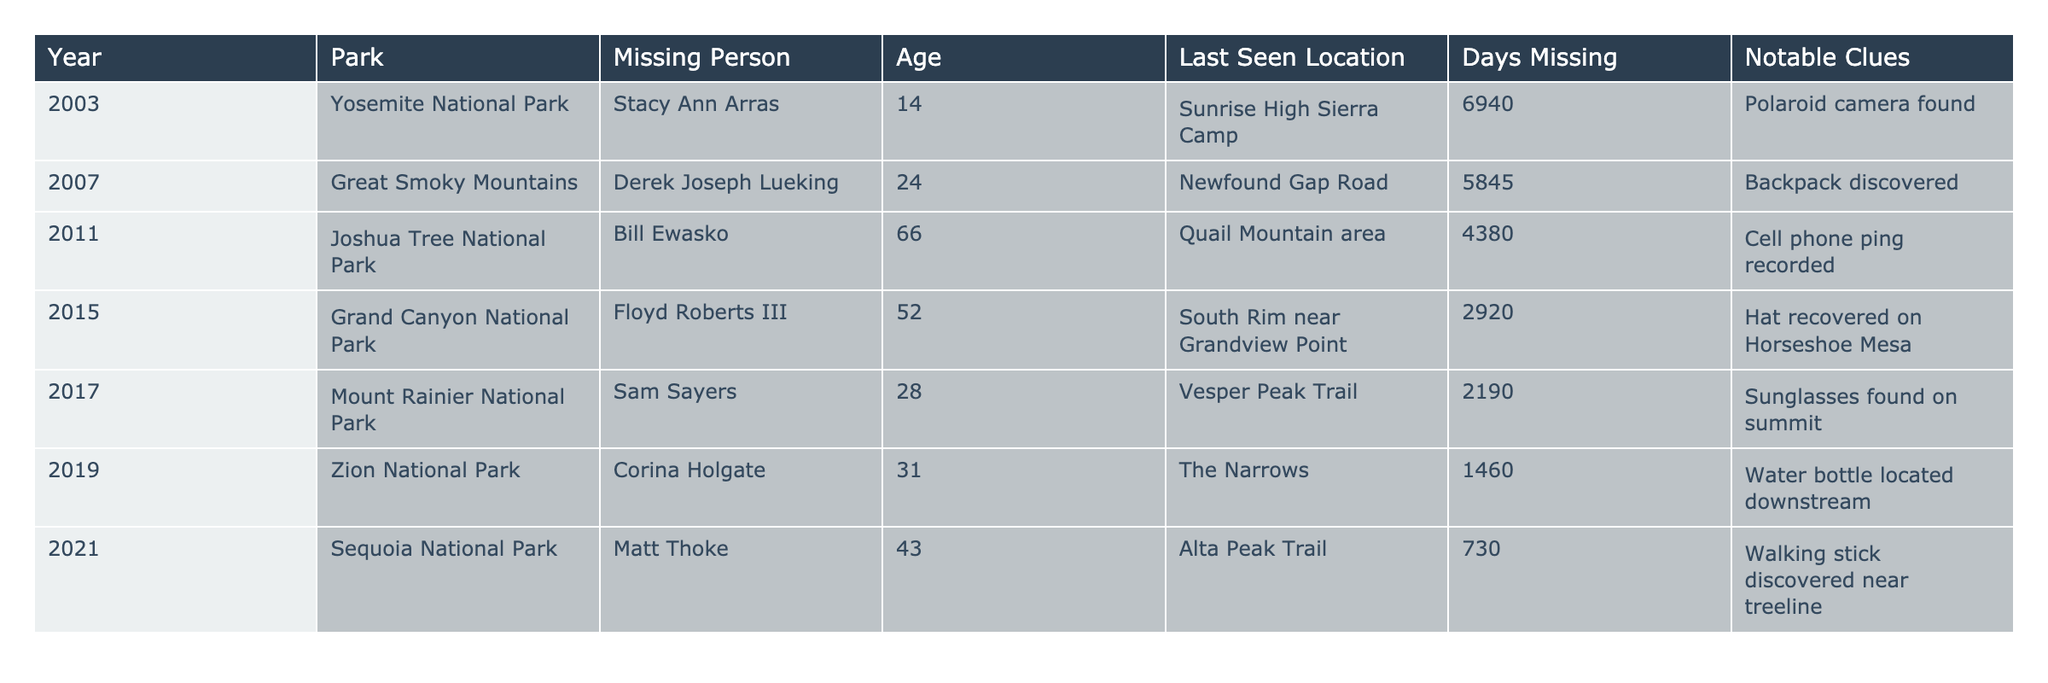What year did the earliest disappearance occur? The earliest disappearance listed is from 2003, as it is the first year in the table.
Answer: 2003 How many days was Stacy Ann Arras missing? According to the table, Stacy Ann Arras was missing for 6940 days.
Answer: 6940 days Which park had a missing person that was last seen at a trail? Sam Sayers from Mount Rainier National Park was last seen on Vesper Peak Trail, which is classified as a trail.
Answer: Mount Rainier National Park What is the age of the youngest missing person listed? The youngest missing person is Stacy Ann Arras, who was 14 years old.
Answer: 14 years old How many days were the total missing persons across all years? To find the total, we sum up the days missing: 6940 + 5845 + 4380 + 2920 + 2190 + 1460 + 730 = 18665 days in total.
Answer: 18665 days Did any of the missing persons have notable clues associated with their disappearance? Yes, all the missing persons listed have notable clues mentioned in the table.
Answer: Yes Which missing person was last seen in the Grand Canyon National Park? Floyd Roberts III, who was 52 years old, is the individual last seen in Grand Canyon National Park.
Answer: Floyd Roberts III How many missing persons were recorded in national parks in 2011? Only one missing person, Bill Ewasko, is recorded in 2011, as that is the only entry for that year.
Answer: 1 What is the age difference between the oldest and youngest missing persons? The oldest missing person is Bill Ewasko at 66 years, and the youngest is Stacy Ann Arras at 14 years. The difference is 66 - 14 = 52 years.
Answer: 52 years Which national park had the shortest duration of disappearance? Matt Thoke in Sequoia National Park had the shortest disappearance duration of 730 days, as seen in the "Days Missing" column.
Answer: Sequoia National Park 